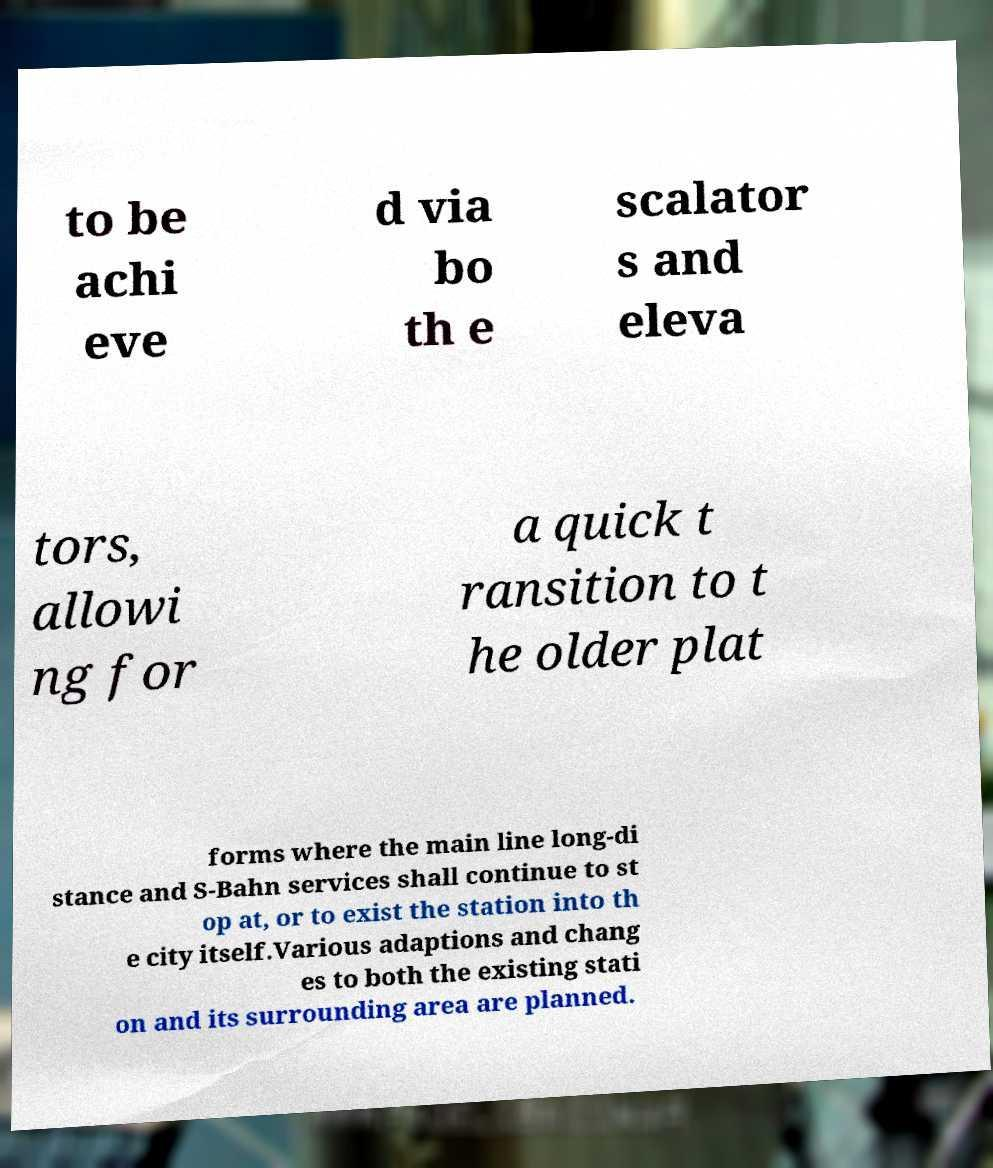Could you extract and type out the text from this image? to be achi eve d via bo th e scalator s and eleva tors, allowi ng for a quick t ransition to t he older plat forms where the main line long-di stance and S-Bahn services shall continue to st op at, or to exist the station into th e city itself.Various adaptions and chang es to both the existing stati on and its surrounding area are planned. 